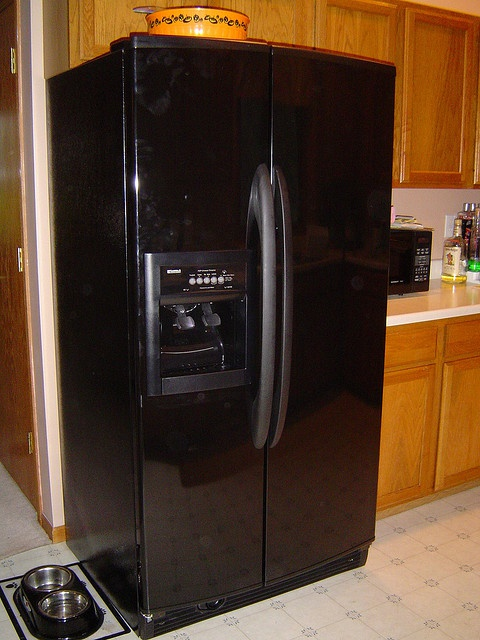Describe the objects in this image and their specific colors. I can see refrigerator in black and gray tones, bowl in black, orange, red, and maroon tones, microwave in black, gray, and maroon tones, bottle in black, tan, and gray tones, and bowl in black, gray, darkgreen, and darkgray tones in this image. 